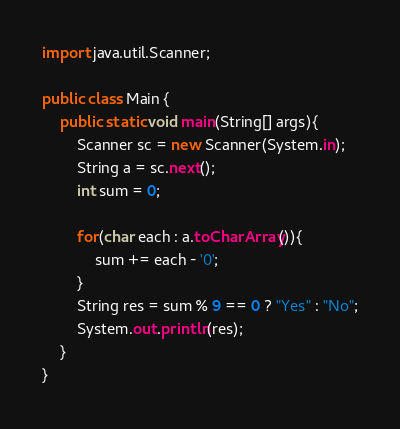Convert code to text. <code><loc_0><loc_0><loc_500><loc_500><_Java_>import java.util.Scanner;

public class Main {
    public static void main(String[] args){
        Scanner sc = new Scanner(System.in);
        String a = sc.next();
        int sum = 0;

        for(char each : a.toCharArray()){
            sum += each - '0';
        }
        String res = sum % 9 == 0 ? "Yes" : "No";
        System.out.println(res);
    }
}</code> 